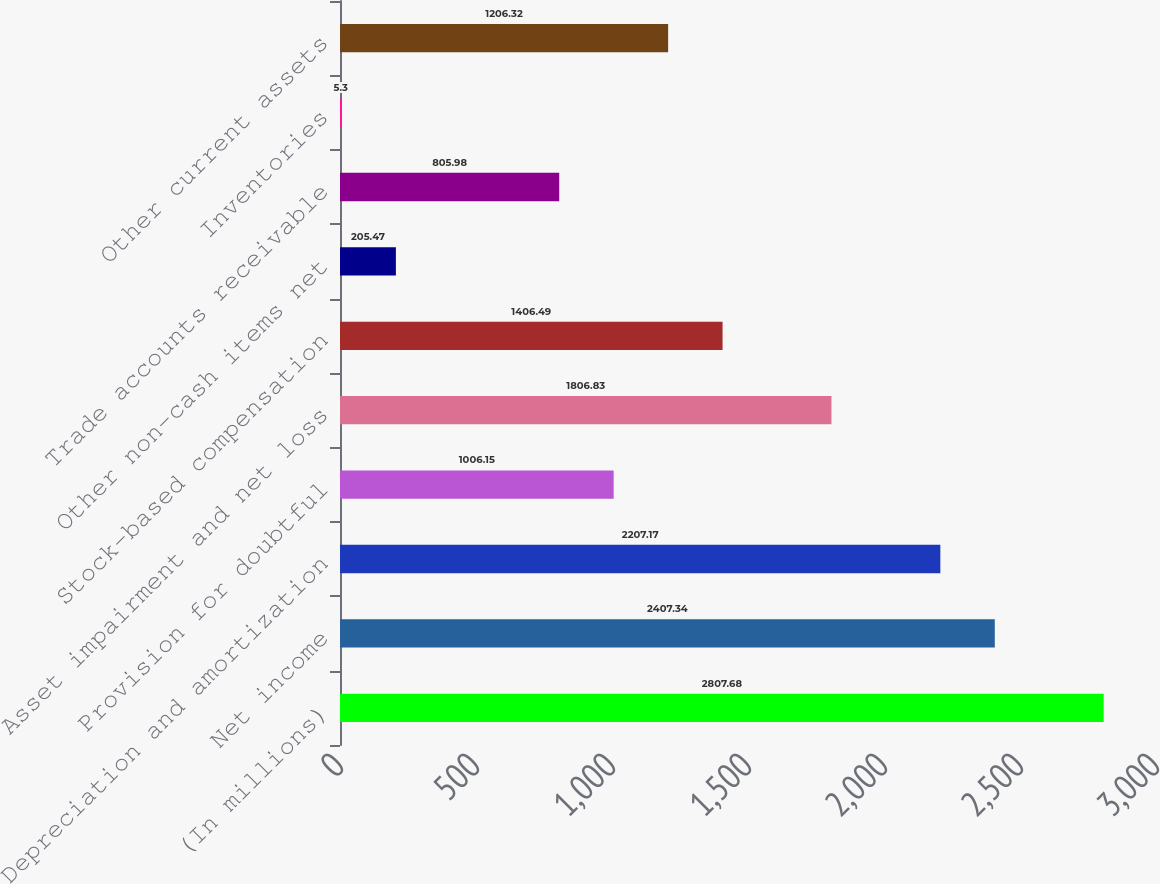Convert chart. <chart><loc_0><loc_0><loc_500><loc_500><bar_chart><fcel>(In millions)<fcel>Net income<fcel>Depreciation and amortization<fcel>Provision for doubtful<fcel>Asset impairment and net loss<fcel>Stock-based compensation<fcel>Other non-cash items net<fcel>Trade accounts receivable<fcel>Inventories<fcel>Other current assets<nl><fcel>2807.68<fcel>2407.34<fcel>2207.17<fcel>1006.15<fcel>1806.83<fcel>1406.49<fcel>205.47<fcel>805.98<fcel>5.3<fcel>1206.32<nl></chart> 